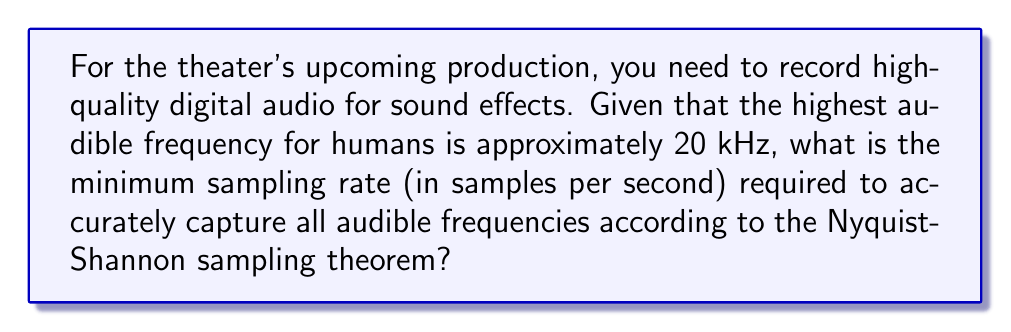Can you solve this math problem? To determine the minimum sampling rate for high-quality digital audio recording, we need to apply the Nyquist-Shannon sampling theorem. This theorem states that to accurately reconstruct a signal, the sampling rate must be at least twice the highest frequency component of the signal.

Step 1: Identify the highest frequency to be captured.
In this case, the highest audible frequency for humans is given as 20 kHz.

Step 2: Apply the Nyquist-Shannon sampling theorem.
The minimum sampling rate (f_s) is calculated as:

$$ f_s = 2 \times f_{max} $$

Where $f_{max}$ is the highest frequency to be captured.

Step 3: Calculate the minimum sampling rate.
$$ f_s = 2 \times 20,000 \text{ Hz} = 40,000 \text{ Hz} = 40 \text{ kHz} $$

Therefore, the minimum sampling rate needed to accurately capture all audible frequencies is 40,000 samples per second or 40 kHz.

In practice, professional audio equipment often uses higher sampling rates (such as 44.1 kHz or 48 kHz) to account for imperfect filters and to provide a margin of safety.
Answer: 40,000 samples per second 